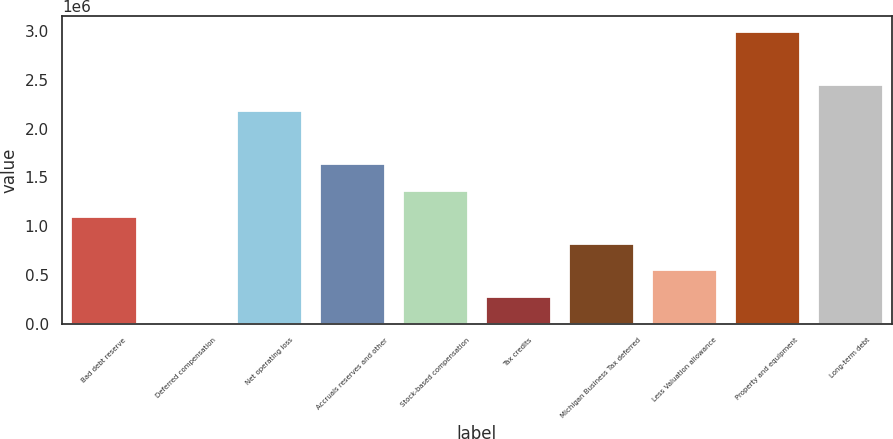Convert chart. <chart><loc_0><loc_0><loc_500><loc_500><bar_chart><fcel>Bad debt reserve<fcel>Deferred compensation<fcel>Net operating loss<fcel>Accruals reserves and other<fcel>Stock-based compensation<fcel>Tax credits<fcel>Michigan Business Tax deferred<fcel>Less Valuation allowance<fcel>Property and equipment<fcel>Long-term debt<nl><fcel>1.10117e+06<fcel>14278<fcel>2.18807e+06<fcel>1.64462e+06<fcel>1.3729e+06<fcel>286002<fcel>829448<fcel>557725<fcel>3.00324e+06<fcel>2.45979e+06<nl></chart> 